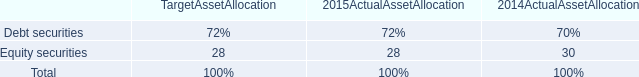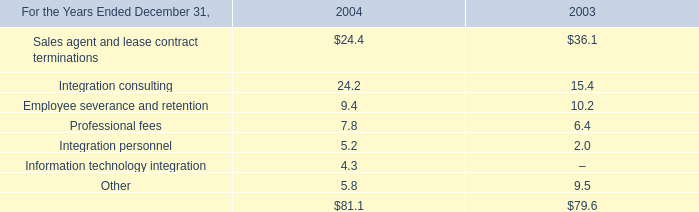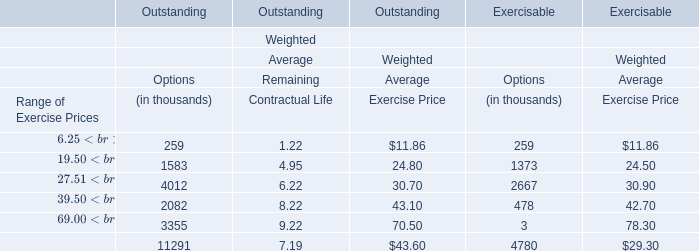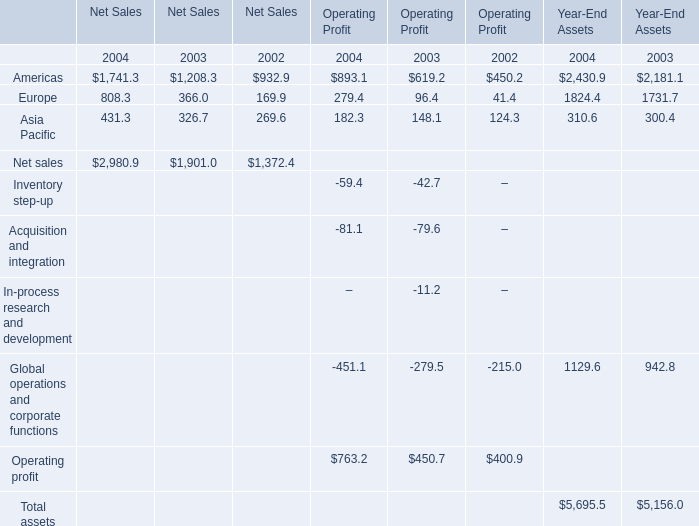What is the growing rate of Asia Pacific for Operating Profit in the year with the most Europe of operating profit? 
Computations: ((893.1 - 619.2) / 619.2)
Answer: 0.44234. 